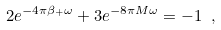Convert formula to latex. <formula><loc_0><loc_0><loc_500><loc_500>2 e ^ { - 4 \pi \beta _ { + } \omega } + 3 e ^ { - 8 \pi M \omega } = - 1 \ ,</formula> 